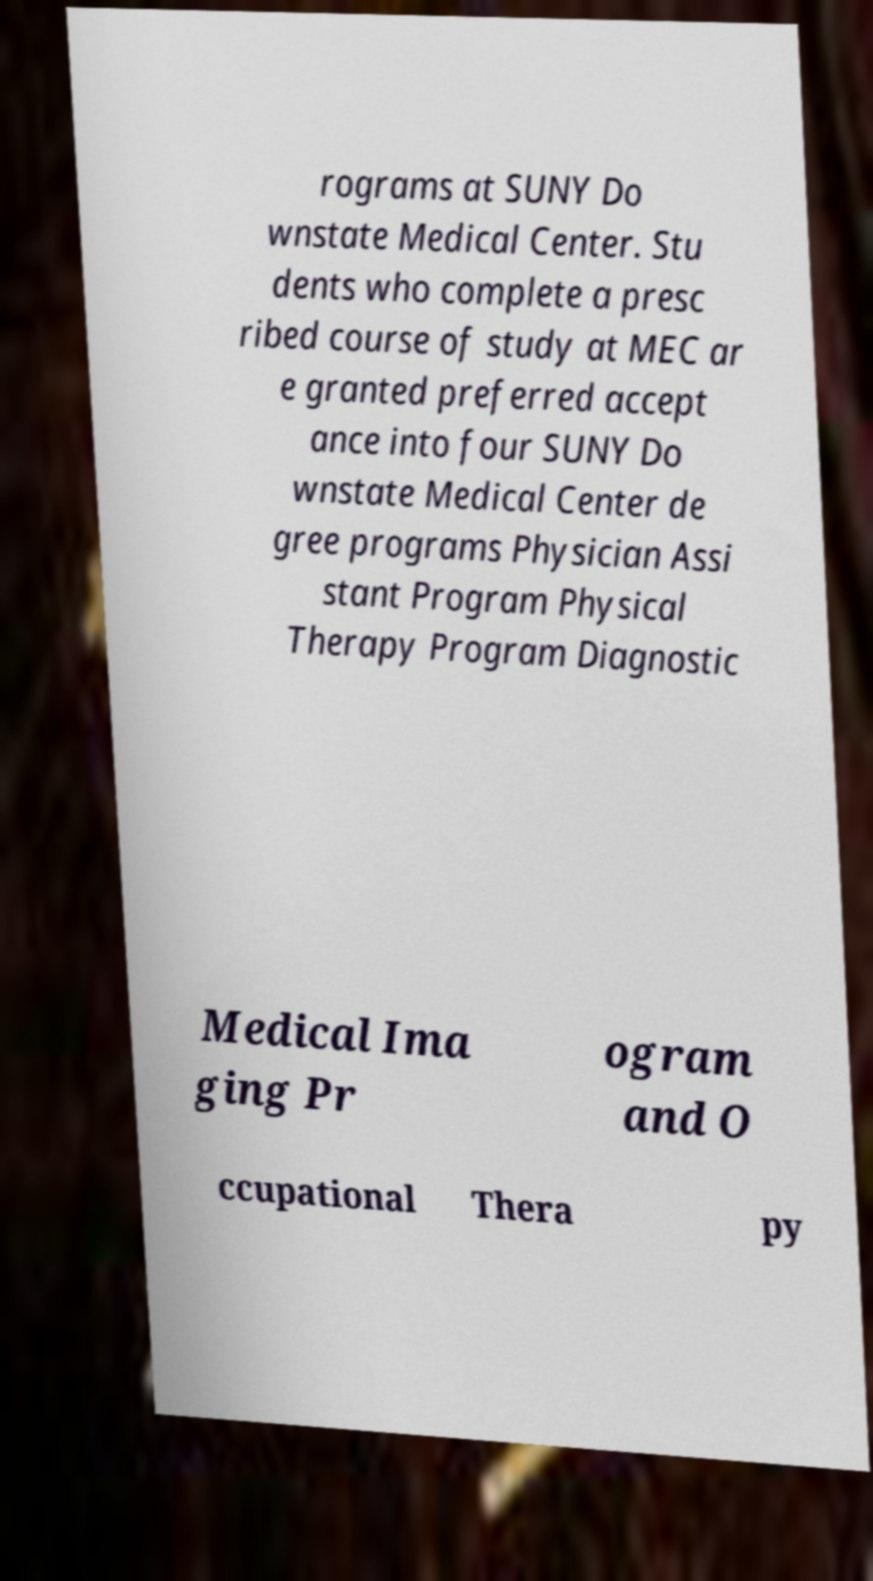There's text embedded in this image that I need extracted. Can you transcribe it verbatim? rograms at SUNY Do wnstate Medical Center. Stu dents who complete a presc ribed course of study at MEC ar e granted preferred accept ance into four SUNY Do wnstate Medical Center de gree programs Physician Assi stant Program Physical Therapy Program Diagnostic Medical Ima ging Pr ogram and O ccupational Thera py 